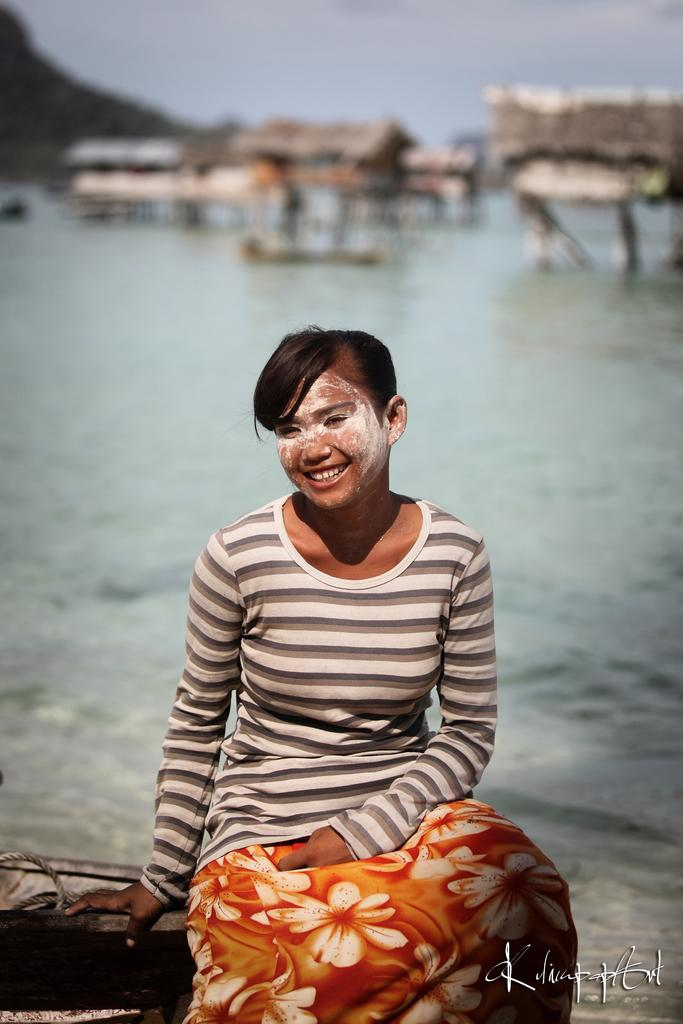Who is the main subject in the image? There is a girl in the image. What is the girl doing in the image? The girl is sitting and smiling. Can you describe the girl's clothing in the image? The girl is wearing a white t-shirt with other colors. What can be seen behind the girl in the image? There is water visible behind the girl. What is visible at the top of the image? The sky is visible at the top of the image. What type of dog is the girl holding in the image? There is no dog present in the image; the girl is sitting and smiling without any visible pets. 